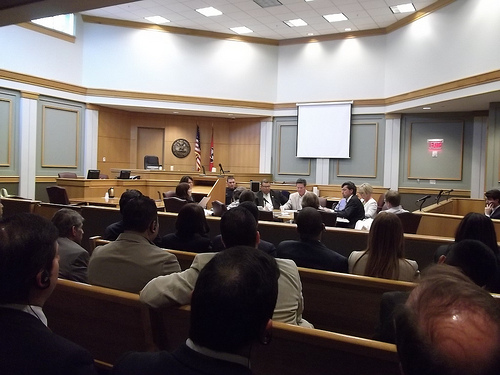<image>
Is the man on the chair? Yes. Looking at the image, I can see the man is positioned on top of the chair, with the chair providing support. Is the man next to the woman? No. The man is not positioned next to the woman. They are located in different areas of the scene. Is the lady above the man? No. The lady is not positioned above the man. The vertical arrangement shows a different relationship. 